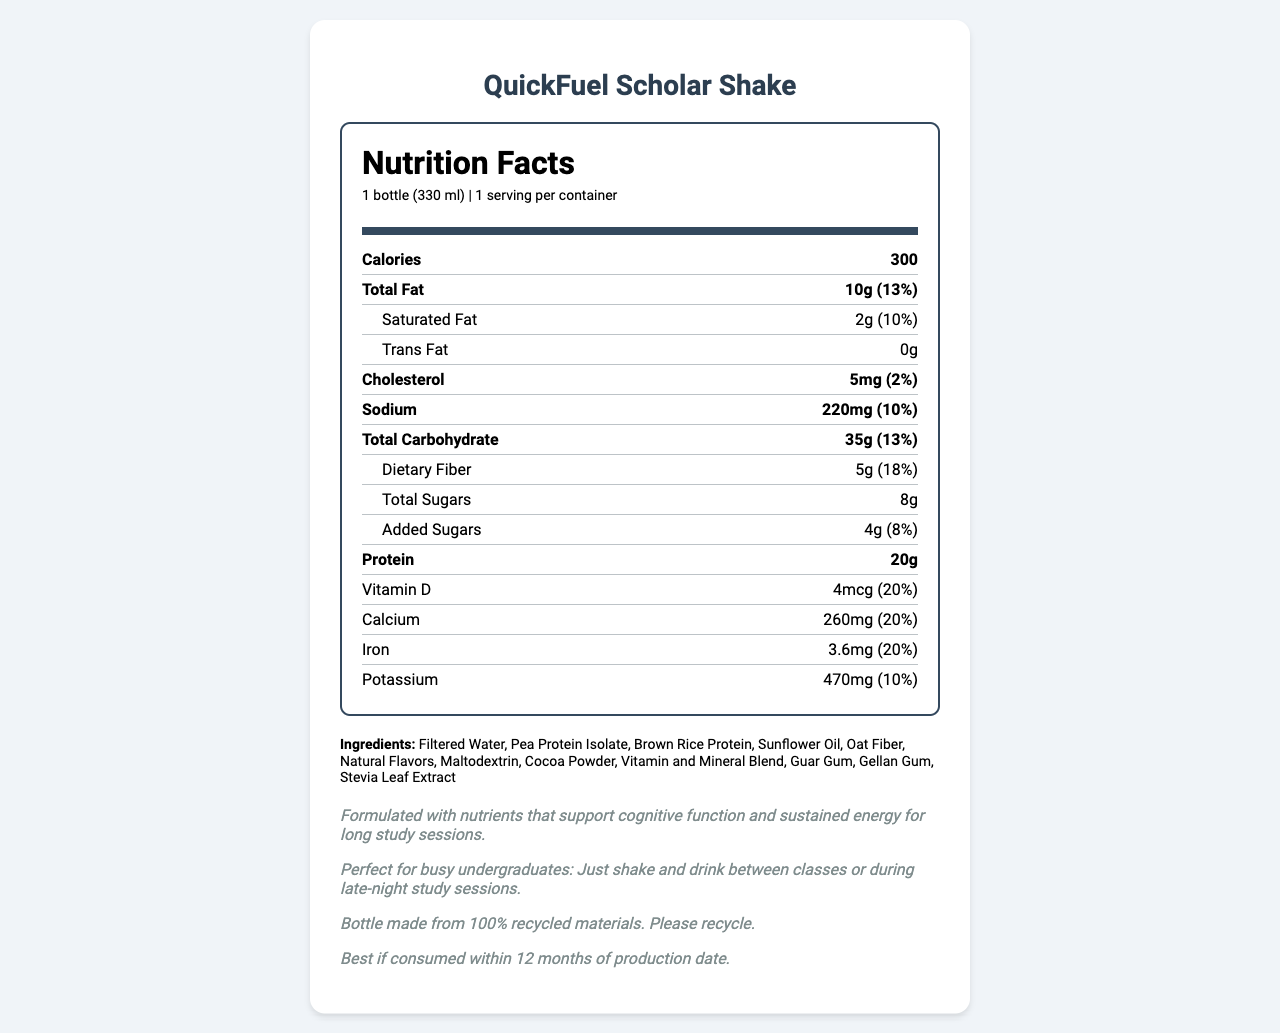what is the serving size of QuickFuel Scholar Shake? The document specifies that the serving size is 1 bottle, which is 330 ml.
Answer: 1 bottle (330 ml) how many calories are in one serving of QuickFuel Scholar Shake? The document lists the total calories per serving as 300.
Answer: 300 what is the amount of protein in one serving? The document states that there are 20 grams of protein per serving.
Answer: 20g which nutrient has the highest daily value percentage? The document lists Vitamin B12 with a daily value of 50%, which is the highest.
Answer: Vitamin B12 what is the total amount of sugars, including added sugars? The document specifies the total sugars as 8g and added sugars as 4g, but added sugars are included in the total sugars count.
Answer: 8g which vitamins are included in the document? A. Vitamin A, Vitamin C, Vitamin D, Vitamin E B. Vitamin B12, Vitamin B6, Vitamin K C. Vitamin A, Vitamin B12, Vitamin E, Vitamin K The document includes Vitamin A, Vitamin C, Vitamin D, and Vitamin E.
Answer: A how much sodium does a QuickFuel Scholar Shake contain? A. 150mg B. 200mg C. 220mg D. 250mg The document lists the sodium content as 220mg.
Answer: C is there any trans fat in the QuickFuel Scholar Shake? The document explicitly states that there are 0g of trans fat.
Answer: No does the QuickFuel Scholar Shake contain any common allergens? The document mentions that it contains no common allergens but is manufactured in a facility that processes milk, soy, and tree nuts.
Answer: No summarize the main characteristics of the QuickFuel Scholar Shake described in this document. The document outlines that the QuickFuel Scholar Shake is suitable for busy undergraduates, providing essential nutrients for cognitive function and sustained energy. It is low in allergens and environmentally friendly, with a shelf life of 12 months.
Answer: The QuickFuel Scholar Shake is a meal replacement shake designed for busy undergraduates. It offers 300 calories per bottle, contains 20g of protein, and provides various vitamins and minerals that support cognitive function and sustained energy. The product is allergen-free and comes in a bottle made from 100% recycled materials. what is the production date of this QuickFuel Scholar Shake? The document does not provide any details on the production date of the product.
Answer: Not enough information what is the shelf life of the QuickFuel Scholar Shake? The document states that the shake is best if consumed within 12 months of the production date.
Answer: 12 months what is the daily value percentage of dietary fiber in this shake? The document shows that the daily value of dietary fiber is 18%.
Answer: 18% determine the main claim about the benefits of the QuickFuel Scholar Shake for undergraduates. The academic performance claim in the document states that the shake is formulated with nutrients that support cognitive function and sustained energy for long study sessions.
Answer: Supports cognitive function and sustained energy for long study sessions 